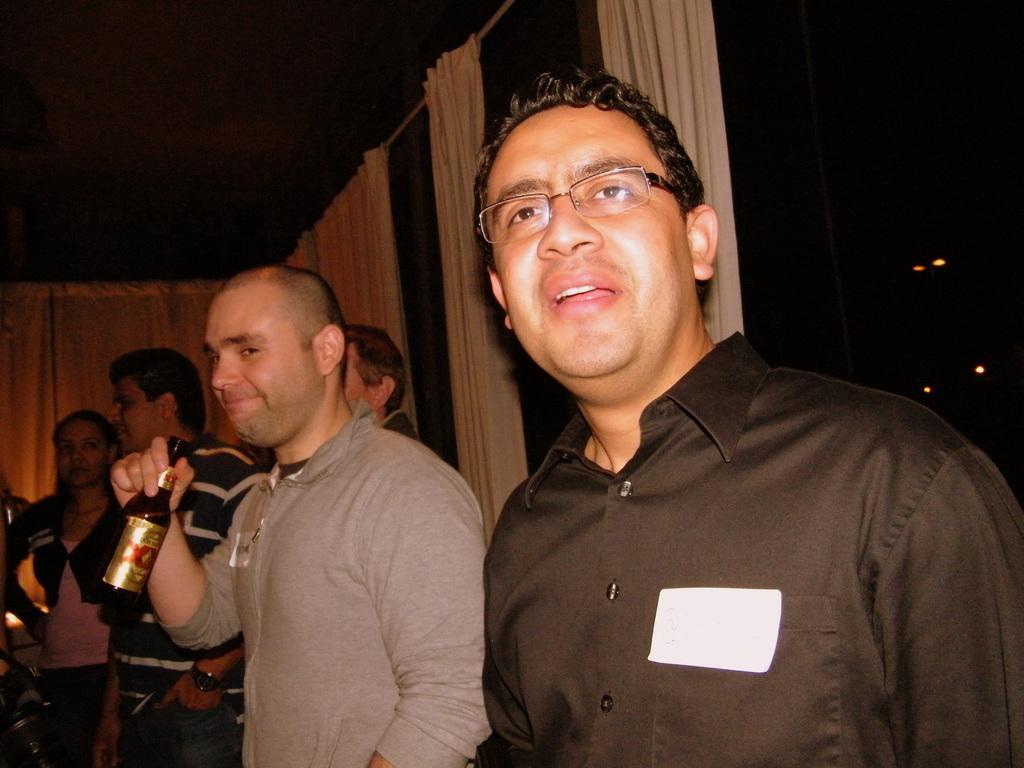How would you summarize this image in a sentence or two? In the image we can see there are men who are standing and the other people are standing and a man in between is holding wine bottle in his hand. 